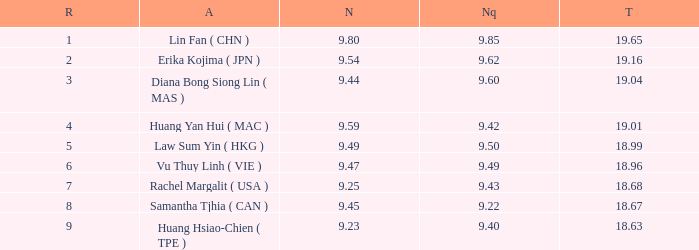Which Nanquan has a Nandao smaller than 9.44, and a Rank smaller than 9, and a Total larger than 18.68? None. 